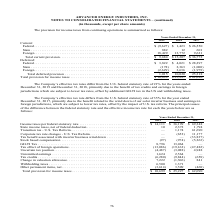From Advanced Energy's financial document, Which periods does the company's effective tax rates differ from the U.S. federal statutory rate? The document shows two values: December 31, 2019 and December 31, 2018. From the document: "Years Ended December 31, 2019 2018 2017 of 21% for the years ended December 31, 2019 and December 31, 2018, primarily due to the benefit of tax credit..." Also, What was the current provision for Federal taxes in 2018? According to the financial document, $1,423 (in thousands). The relevant text states: "Federal . $ (9,627) $ 1,423 $ 26,550 State . 882 12 601 Foreign . 18,429 13,772 9,621 Total current provision . $ 9,684 $ 15,20..." Also, What was the current provision for Foreign taxes in 2019? According to the financial document, 18,429 (in thousands). The relevant text states: "27) $ 1,423 $ 26,550 State . 882 12 601 Foreign . 18,429 13,772 9,621 Total current provision . $ 9,684 $ 15,207 $ 36,772..." Also, can you calculate: What was the change in total current provision between 2017 and 2018? Based on the calculation: $15,207-$36,772, the result is -21565 (in thousands). This is based on the information: ",621 Total current provision . $ 9,684 $ 15,207 $ 36,772 13,772 9,621 Total current provision . $ 9,684 $ 15,207 $ 36,772..." The key data points involved are: 15,207, 36,772. Also, can you calculate: What was the change in Total deferred provision between 2018 and 2019? Based on the calculation: 1,015-10,020, the result is -9005 (in thousands). This is based on the information: "9) 3,636 (1,979) Total deferred provision . 1,015 10,020 25,318 (2,629) 3,636 (1,979) Total deferred provision . 1,015 10,020 25,318..." The key data points involved are: 1,015, 10,020. Also, can you calculate: What was the percentage change in total provision for income taxes between 2017 and 2018? To answer this question, I need to perform calculations using the financial data. The calculation is: ($25,227-$62,090)/$62,090, which equals -59.37 (percentage). This is based on the information: "provision for income taxes . $ 10,699 $ 25,227 $ 62,090 Total provision for income taxes . $ 10,699 $ 25,227 $ 62,090..." The key data points involved are: 25,227, 62,090. 